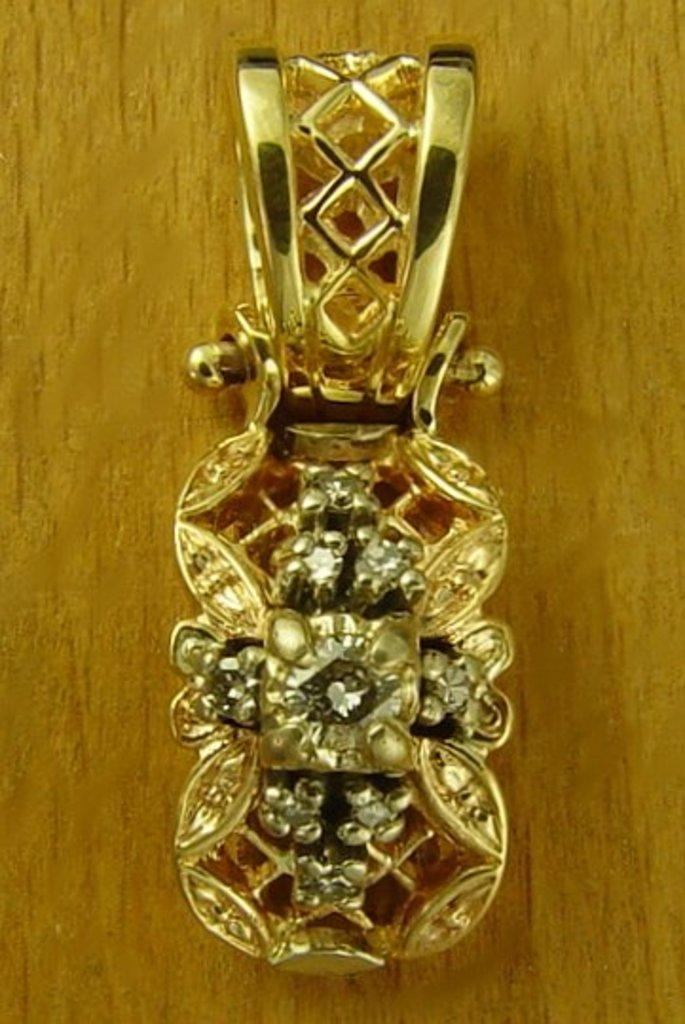What is the main subject of the image? There is an ornament in the image. Where is the ornament located? The ornament is on a table. How is the ornament positioned in the image? The ornament is in the center of the image. What type of paper is being used to hold the ornament in place? There is no paper present in the image, and the ornament is not being held in place by any visible means. 